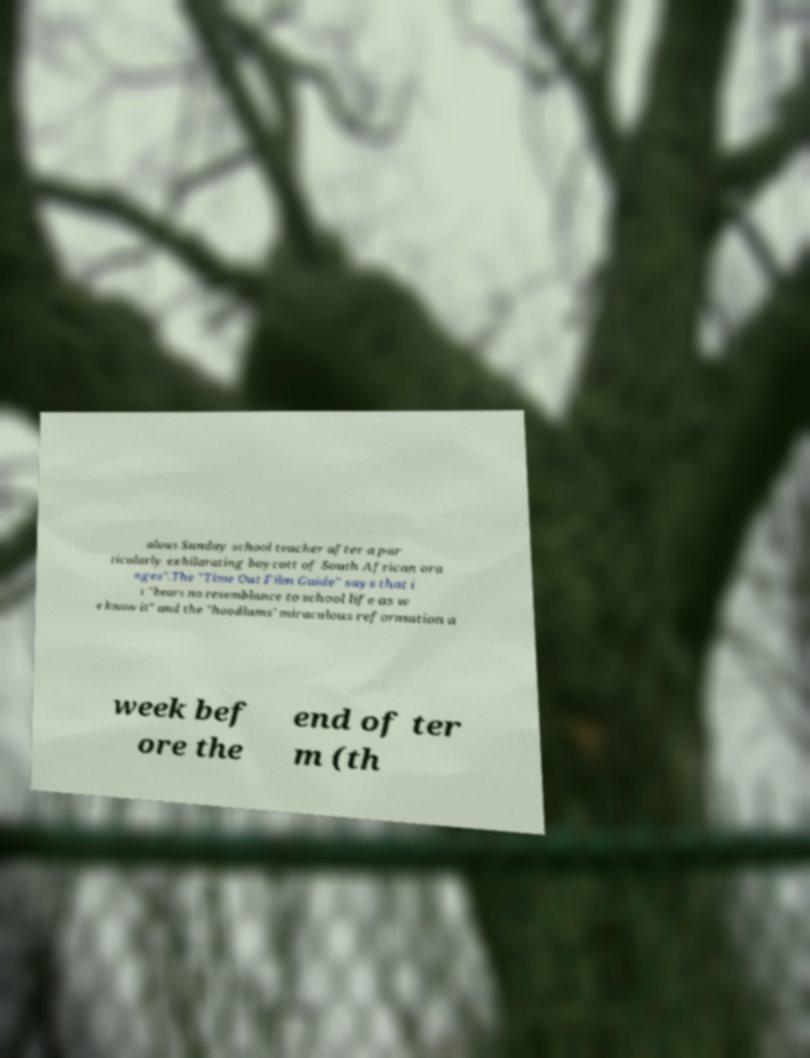Please identify and transcribe the text found in this image. alous Sunday school teacher after a par ticularly exhilarating boycott of South African ora nges".The "Time Out Film Guide" says that i t "bears no resemblance to school life as w e know it" and the "hoodlums' miraculous reformation a week bef ore the end of ter m (th 